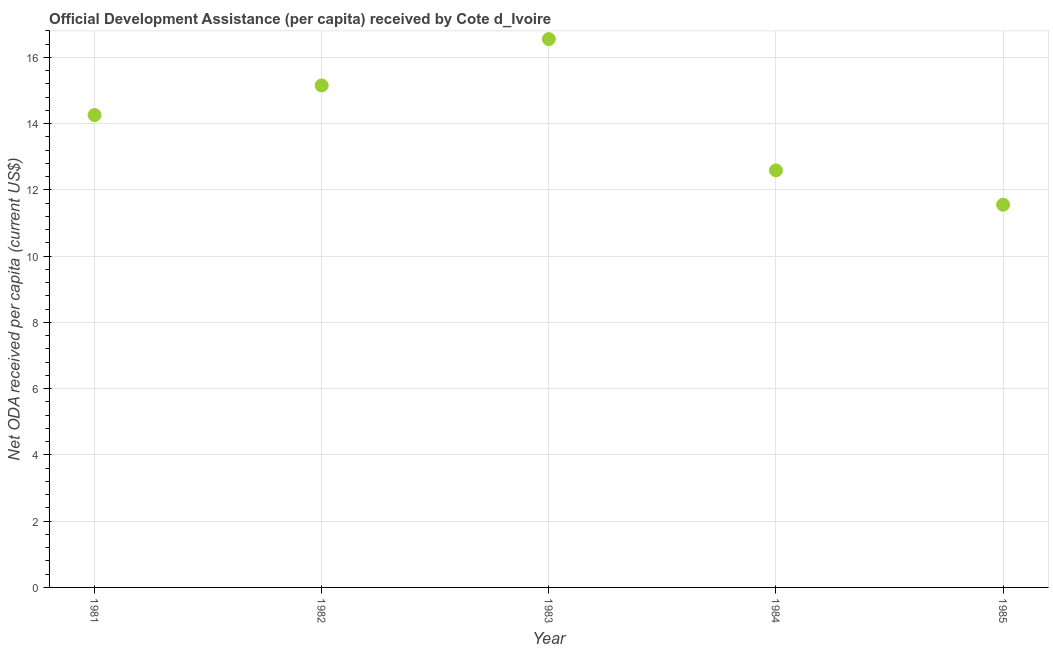What is the net oda received per capita in 1983?
Your response must be concise. 16.55. Across all years, what is the maximum net oda received per capita?
Provide a short and direct response. 16.55. Across all years, what is the minimum net oda received per capita?
Your answer should be compact. 11.55. What is the sum of the net oda received per capita?
Offer a terse response. 70.11. What is the difference between the net oda received per capita in 1982 and 1985?
Your answer should be compact. 3.6. What is the average net oda received per capita per year?
Provide a succinct answer. 14.02. What is the median net oda received per capita?
Your answer should be very brief. 14.26. Do a majority of the years between 1984 and 1985 (inclusive) have net oda received per capita greater than 10 US$?
Keep it short and to the point. Yes. What is the ratio of the net oda received per capita in 1981 to that in 1984?
Your answer should be very brief. 1.13. Is the net oda received per capita in 1984 less than that in 1985?
Provide a short and direct response. No. Is the difference between the net oda received per capita in 1983 and 1985 greater than the difference between any two years?
Make the answer very short. Yes. What is the difference between the highest and the second highest net oda received per capita?
Ensure brevity in your answer.  1.4. What is the difference between the highest and the lowest net oda received per capita?
Provide a short and direct response. 5. Does the net oda received per capita monotonically increase over the years?
Make the answer very short. No. How many dotlines are there?
Make the answer very short. 1. Does the graph contain any zero values?
Provide a succinct answer. No. What is the title of the graph?
Your answer should be compact. Official Development Assistance (per capita) received by Cote d_Ivoire. What is the label or title of the Y-axis?
Give a very brief answer. Net ODA received per capita (current US$). What is the Net ODA received per capita (current US$) in 1981?
Provide a succinct answer. 14.26. What is the Net ODA received per capita (current US$) in 1982?
Your answer should be very brief. 15.15. What is the Net ODA received per capita (current US$) in 1983?
Your answer should be very brief. 16.55. What is the Net ODA received per capita (current US$) in 1984?
Offer a terse response. 12.59. What is the Net ODA received per capita (current US$) in 1985?
Give a very brief answer. 11.55. What is the difference between the Net ODA received per capita (current US$) in 1981 and 1982?
Make the answer very short. -0.89. What is the difference between the Net ODA received per capita (current US$) in 1981 and 1983?
Provide a succinct answer. -2.29. What is the difference between the Net ODA received per capita (current US$) in 1981 and 1984?
Ensure brevity in your answer.  1.67. What is the difference between the Net ODA received per capita (current US$) in 1981 and 1985?
Offer a terse response. 2.71. What is the difference between the Net ODA received per capita (current US$) in 1982 and 1983?
Provide a short and direct response. -1.4. What is the difference between the Net ODA received per capita (current US$) in 1982 and 1984?
Give a very brief answer. 2.57. What is the difference between the Net ODA received per capita (current US$) in 1982 and 1985?
Provide a succinct answer. 3.6. What is the difference between the Net ODA received per capita (current US$) in 1983 and 1984?
Your answer should be compact. 3.96. What is the difference between the Net ODA received per capita (current US$) in 1983 and 1985?
Give a very brief answer. 5. What is the difference between the Net ODA received per capita (current US$) in 1984 and 1985?
Keep it short and to the point. 1.04. What is the ratio of the Net ODA received per capita (current US$) in 1981 to that in 1982?
Make the answer very short. 0.94. What is the ratio of the Net ODA received per capita (current US$) in 1981 to that in 1983?
Provide a short and direct response. 0.86. What is the ratio of the Net ODA received per capita (current US$) in 1981 to that in 1984?
Offer a very short reply. 1.13. What is the ratio of the Net ODA received per capita (current US$) in 1981 to that in 1985?
Your answer should be very brief. 1.23. What is the ratio of the Net ODA received per capita (current US$) in 1982 to that in 1983?
Ensure brevity in your answer.  0.92. What is the ratio of the Net ODA received per capita (current US$) in 1982 to that in 1984?
Give a very brief answer. 1.2. What is the ratio of the Net ODA received per capita (current US$) in 1982 to that in 1985?
Offer a terse response. 1.31. What is the ratio of the Net ODA received per capita (current US$) in 1983 to that in 1984?
Offer a terse response. 1.31. What is the ratio of the Net ODA received per capita (current US$) in 1983 to that in 1985?
Provide a short and direct response. 1.43. What is the ratio of the Net ODA received per capita (current US$) in 1984 to that in 1985?
Your answer should be compact. 1.09. 